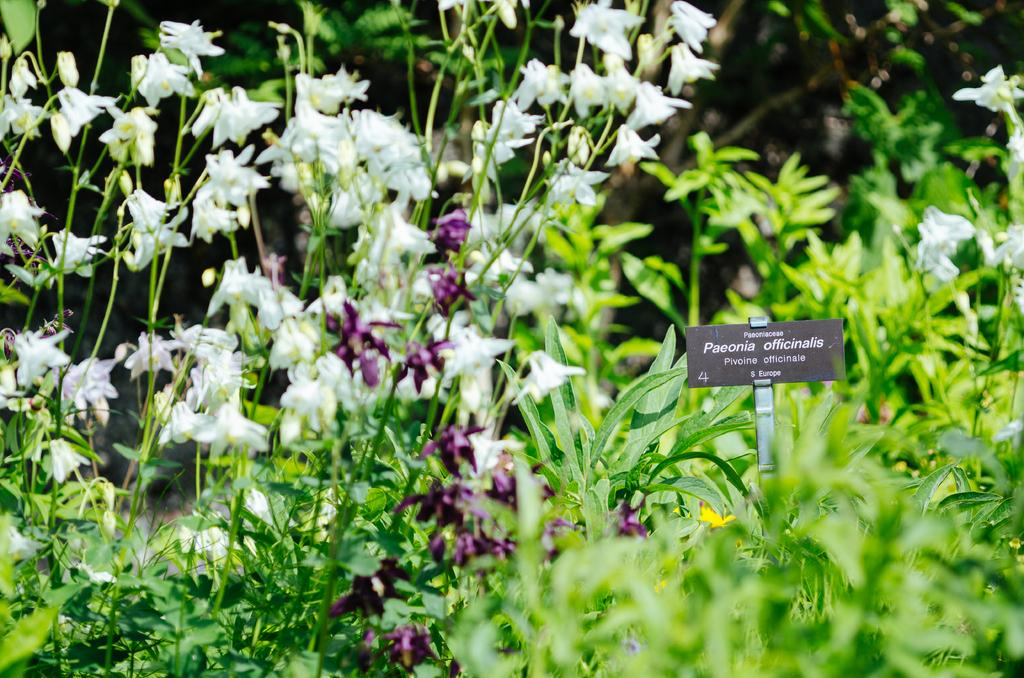What type of living organisms can be seen in the image? There are plants in the image. What color are the flowers on the plants? The flowers on the plants are white and purple. What is located on the right side of the image? There is a board on the right side of the image. What is written on the board? There is writing on the board. Can you see a giraffe waving its front leg in the image? No, there is no giraffe or waving motion present in the image. 